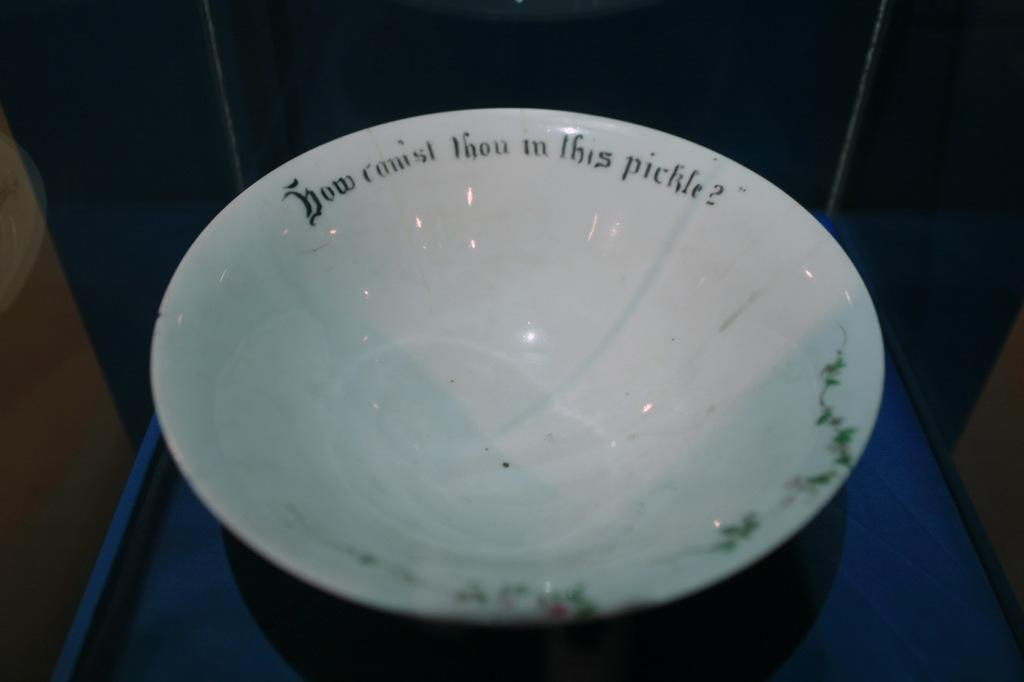What colors are present in the image? The image contains white, black, and blue colors. What is written on the bowl in the image? There is black color text on a white color bowl. What is the surface on which the bowl is placed? The bowl is placed on a blue color surface. How would you describe the overall lighting or brightness in the image? The background of the image is dark. How many rabbits can be seen in the image? There are no rabbits present in the image. What time is indicated by the hour on the clock in the image? There is no clock present in the image. 